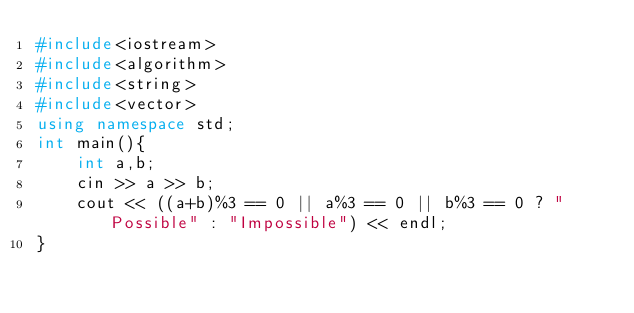Convert code to text. <code><loc_0><loc_0><loc_500><loc_500><_C++_>#include<iostream>
#include<algorithm>
#include<string>
#include<vector>
using namespace std;
int main(){
    int a,b;
    cin >> a >> b;
    cout << ((a+b)%3 == 0 || a%3 == 0 || b%3 == 0 ? "Possible" : "Impossible") << endl;
}</code> 